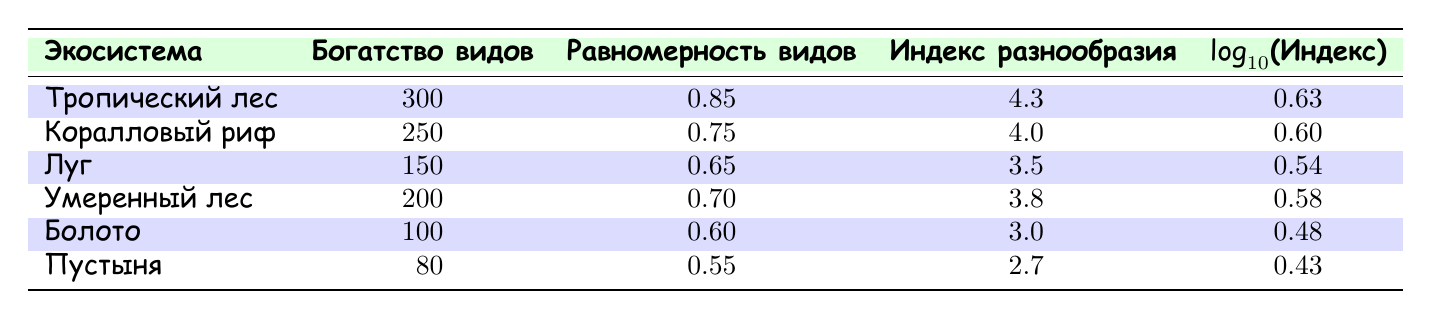What is the species richness of the Tropical Rainforest? The species richness is clearly stated in the table under the "Богатство видов" column for the Tropical Rainforest row. The value is 300.
Answer: 300 What is the diversity index of the Wetland? The diversity index can be found in the "Индекс разнообразия" column for the Wetland row. The value is 3.0.
Answer: 3.0 Which ecosystem has the highest species evenness? To find the ecosystem with the highest species evenness, we look under the "Равномерность видов" column. The highest number in the table is 0.85 for the Tropical Rainforest.
Answer: Tropical Rainforest What is the difference between the species richness of the Coral Reef and the Desert? We take the values for species richness from each row: Coral Reef is 250 and Desert is 80. The difference is calculated by subtracting 80 from 250, giving us 170.
Answer: 170 Is the species evenness greater than 0.70 in the Temperate Forest? We look at the species evenness value for the Temperate Forest, found in the "Равномерность видов" column, which is 0.70. As it is not greater than 0.70, the answer is no.
Answer: No What is the average diversity index of all listed ecosystems? First, we add up all the diversity index values: 4.3 + 4.0 + 3.5 + 3.8 + 3.0 + 2.7 = 21.3. Then we divide by the number of ecosystems, which is 6, yielding 21.3/6 = 3.55.
Answer: 3.55 Which ecosystem has a diversity index closest to 2.5? Checking the diversity indices listed, we see that the Desert has the lowest index at 2.7, which is closest to 2.5.
Answer: Desert Is the species richness of Grassland less than 150? The species richness of Grassland is stated to be 150. Since it is not less than 150, the answer is no.
Answer: No What is the relationship between species evenness and diversity index in the ecosystems? When comparing the "Равномерность видов" and "Индекс разнообразия" columns across ecosystems, there isn’t a consistent direct relationship; for example, both the Tropical Rainforest (0.85, 4.3) and the Desert (0.55, 2.7) show differing levels of diversity index despite varying evenness values. This shows that while species evenness may influence diversity, many factors play a role.
Answer: Complex relationship 